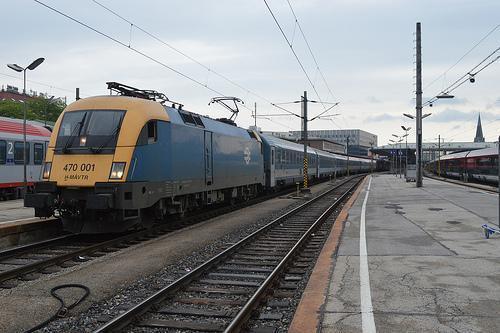How many trains are visible?
Give a very brief answer. 3. How many trains are in the picture?
Give a very brief answer. 3. How many poles are in the picture?
Give a very brief answer. 3. 